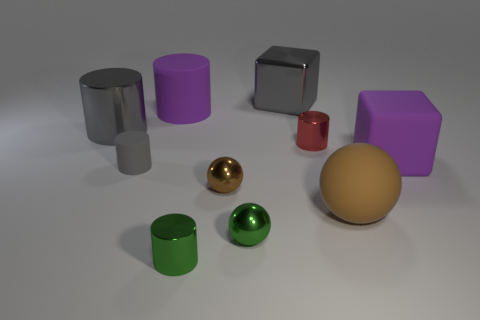Are there an equal number of large gray objects on the left side of the tiny gray object and brown rubber balls?
Offer a very short reply. Yes. What number of objects are either small gray cylinders that are behind the tiny brown thing or green things?
Provide a short and direct response. 3. There is a large metal object that is on the right side of the brown metallic object; is it the same color as the big metal cylinder?
Ensure brevity in your answer.  Yes. How big is the matte cylinder that is behind the rubber cube?
Offer a very short reply. Large. What is the shape of the small object to the right of the large metal object that is to the right of the tiny green metallic cylinder?
Offer a very short reply. Cylinder. What color is the other small matte thing that is the same shape as the small red object?
Offer a terse response. Gray. There is a brown object that is to the right of the brown shiny ball; is it the same size as the large purple cylinder?
Offer a terse response. Yes. The shiny object that is the same color as the large ball is what shape?
Offer a terse response. Sphere. How many other objects have the same material as the red object?
Your answer should be compact. 5. There is a object that is behind the purple matte object that is behind the matte object on the right side of the matte ball; what is its material?
Provide a short and direct response. Metal. 